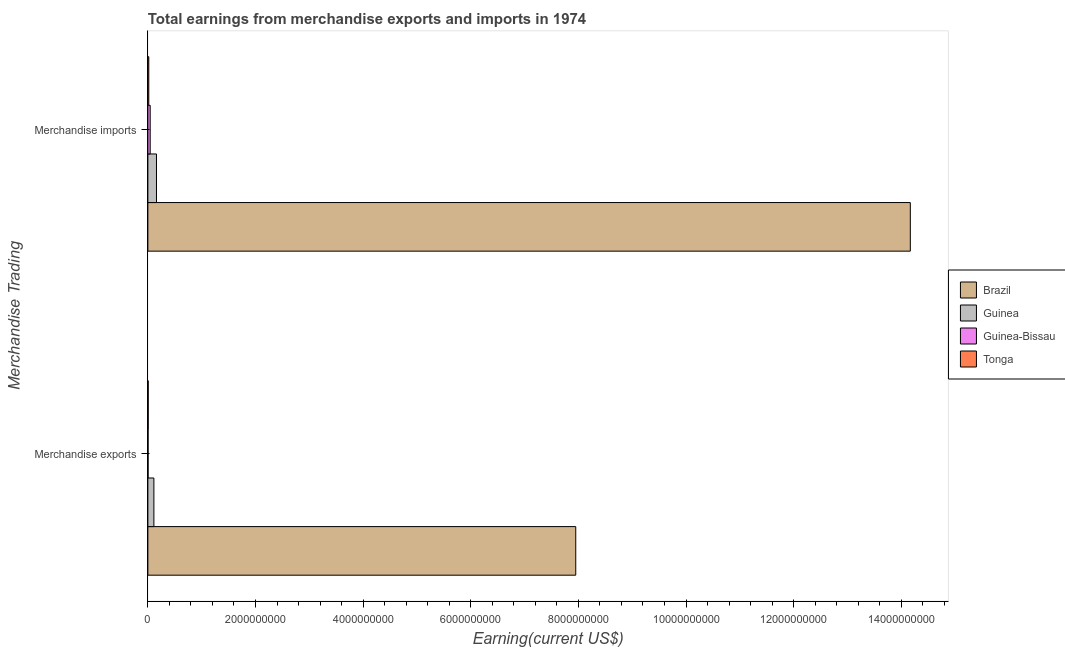How many different coloured bars are there?
Keep it short and to the point. 4. How many groups of bars are there?
Offer a terse response. 2. Are the number of bars on each tick of the Y-axis equal?
Provide a succinct answer. Yes. How many bars are there on the 1st tick from the top?
Keep it short and to the point. 4. How many bars are there on the 1st tick from the bottom?
Keep it short and to the point. 4. What is the label of the 1st group of bars from the top?
Give a very brief answer. Merchandise imports. What is the earnings from merchandise imports in Tonga?
Give a very brief answer. 1.70e+07. Across all countries, what is the maximum earnings from merchandise exports?
Provide a short and direct response. 7.95e+09. Across all countries, what is the minimum earnings from merchandise imports?
Your answer should be very brief. 1.70e+07. In which country was the earnings from merchandise imports maximum?
Offer a terse response. Brazil. In which country was the earnings from merchandise exports minimum?
Your response must be concise. Guinea-Bissau. What is the total earnings from merchandise exports in the graph?
Provide a short and direct response. 8.07e+09. What is the difference between the earnings from merchandise exports in Guinea-Bissau and that in Tonga?
Make the answer very short. -2.74e+06. What is the difference between the earnings from merchandise exports in Brazil and the earnings from merchandise imports in Tonga?
Give a very brief answer. 7.93e+09. What is the average earnings from merchandise exports per country?
Your answer should be very brief. 2.02e+09. What is the difference between the earnings from merchandise imports and earnings from merchandise exports in Tonga?
Your response must be concise. 1.04e+07. What is the ratio of the earnings from merchandise imports in Tonga to that in Brazil?
Provide a short and direct response. 0. Is the earnings from merchandise imports in Guinea-Bissau less than that in Tonga?
Offer a very short reply. No. What does the 4th bar from the top in Merchandise imports represents?
Your response must be concise. Brazil. What does the 4th bar from the bottom in Merchandise exports represents?
Ensure brevity in your answer.  Tonga. Are all the bars in the graph horizontal?
Provide a short and direct response. Yes. How many countries are there in the graph?
Ensure brevity in your answer.  4. What is the difference between two consecutive major ticks on the X-axis?
Give a very brief answer. 2.00e+09. Does the graph contain grids?
Provide a succinct answer. No. Where does the legend appear in the graph?
Give a very brief answer. Center right. How many legend labels are there?
Keep it short and to the point. 4. What is the title of the graph?
Give a very brief answer. Total earnings from merchandise exports and imports in 1974. What is the label or title of the X-axis?
Provide a short and direct response. Earning(current US$). What is the label or title of the Y-axis?
Your answer should be very brief. Merchandise Trading. What is the Earning(current US$) of Brazil in Merchandise exports?
Keep it short and to the point. 7.95e+09. What is the Earning(current US$) in Guinea in Merchandise exports?
Your answer should be very brief. 1.12e+08. What is the Earning(current US$) of Guinea-Bissau in Merchandise exports?
Offer a terse response. 3.87e+06. What is the Earning(current US$) in Tonga in Merchandise exports?
Offer a terse response. 6.61e+06. What is the Earning(current US$) of Brazil in Merchandise imports?
Provide a succinct answer. 1.42e+1. What is the Earning(current US$) of Guinea in Merchandise imports?
Your answer should be compact. 1.60e+08. What is the Earning(current US$) of Guinea-Bissau in Merchandise imports?
Provide a short and direct response. 4.31e+07. What is the Earning(current US$) in Tonga in Merchandise imports?
Give a very brief answer. 1.70e+07. Across all Merchandise Trading, what is the maximum Earning(current US$) in Brazil?
Offer a terse response. 1.42e+1. Across all Merchandise Trading, what is the maximum Earning(current US$) of Guinea?
Keep it short and to the point. 1.60e+08. Across all Merchandise Trading, what is the maximum Earning(current US$) of Guinea-Bissau?
Provide a short and direct response. 4.31e+07. Across all Merchandise Trading, what is the maximum Earning(current US$) of Tonga?
Keep it short and to the point. 1.70e+07. Across all Merchandise Trading, what is the minimum Earning(current US$) in Brazil?
Make the answer very short. 7.95e+09. Across all Merchandise Trading, what is the minimum Earning(current US$) of Guinea?
Offer a terse response. 1.12e+08. Across all Merchandise Trading, what is the minimum Earning(current US$) of Guinea-Bissau?
Offer a very short reply. 3.87e+06. Across all Merchandise Trading, what is the minimum Earning(current US$) of Tonga?
Offer a very short reply. 6.61e+06. What is the total Earning(current US$) of Brazil in the graph?
Make the answer very short. 2.21e+1. What is the total Earning(current US$) of Guinea in the graph?
Ensure brevity in your answer.  2.72e+08. What is the total Earning(current US$) of Guinea-Bissau in the graph?
Your response must be concise. 4.70e+07. What is the total Earning(current US$) of Tonga in the graph?
Your answer should be very brief. 2.36e+07. What is the difference between the Earning(current US$) of Brazil in Merchandise exports and that in Merchandise imports?
Your answer should be compact. -6.22e+09. What is the difference between the Earning(current US$) of Guinea in Merchandise exports and that in Merchandise imports?
Provide a succinct answer. -4.80e+07. What is the difference between the Earning(current US$) of Guinea-Bissau in Merchandise exports and that in Merchandise imports?
Your answer should be very brief. -3.92e+07. What is the difference between the Earning(current US$) of Tonga in Merchandise exports and that in Merchandise imports?
Make the answer very short. -1.04e+07. What is the difference between the Earning(current US$) of Brazil in Merchandise exports and the Earning(current US$) of Guinea in Merchandise imports?
Offer a terse response. 7.79e+09. What is the difference between the Earning(current US$) of Brazil in Merchandise exports and the Earning(current US$) of Guinea-Bissau in Merchandise imports?
Give a very brief answer. 7.91e+09. What is the difference between the Earning(current US$) of Brazil in Merchandise exports and the Earning(current US$) of Tonga in Merchandise imports?
Give a very brief answer. 7.93e+09. What is the difference between the Earning(current US$) in Guinea in Merchandise exports and the Earning(current US$) in Guinea-Bissau in Merchandise imports?
Keep it short and to the point. 6.89e+07. What is the difference between the Earning(current US$) in Guinea in Merchandise exports and the Earning(current US$) in Tonga in Merchandise imports?
Offer a very short reply. 9.50e+07. What is the difference between the Earning(current US$) in Guinea-Bissau in Merchandise exports and the Earning(current US$) in Tonga in Merchandise imports?
Your response must be concise. -1.31e+07. What is the average Earning(current US$) of Brazil per Merchandise Trading?
Give a very brief answer. 1.11e+1. What is the average Earning(current US$) in Guinea per Merchandise Trading?
Keep it short and to the point. 1.36e+08. What is the average Earning(current US$) of Guinea-Bissau per Merchandise Trading?
Offer a terse response. 2.35e+07. What is the average Earning(current US$) of Tonga per Merchandise Trading?
Make the answer very short. 1.18e+07. What is the difference between the Earning(current US$) of Brazil and Earning(current US$) of Guinea in Merchandise exports?
Give a very brief answer. 7.84e+09. What is the difference between the Earning(current US$) of Brazil and Earning(current US$) of Guinea-Bissau in Merchandise exports?
Offer a very short reply. 7.95e+09. What is the difference between the Earning(current US$) of Brazil and Earning(current US$) of Tonga in Merchandise exports?
Keep it short and to the point. 7.94e+09. What is the difference between the Earning(current US$) of Guinea and Earning(current US$) of Guinea-Bissau in Merchandise exports?
Your response must be concise. 1.08e+08. What is the difference between the Earning(current US$) in Guinea and Earning(current US$) in Tonga in Merchandise exports?
Make the answer very short. 1.05e+08. What is the difference between the Earning(current US$) of Guinea-Bissau and Earning(current US$) of Tonga in Merchandise exports?
Give a very brief answer. -2.74e+06. What is the difference between the Earning(current US$) of Brazil and Earning(current US$) of Guinea in Merchandise imports?
Your response must be concise. 1.40e+1. What is the difference between the Earning(current US$) of Brazil and Earning(current US$) of Guinea-Bissau in Merchandise imports?
Your response must be concise. 1.41e+1. What is the difference between the Earning(current US$) in Brazil and Earning(current US$) in Tonga in Merchandise imports?
Make the answer very short. 1.42e+1. What is the difference between the Earning(current US$) of Guinea and Earning(current US$) of Guinea-Bissau in Merchandise imports?
Ensure brevity in your answer.  1.17e+08. What is the difference between the Earning(current US$) of Guinea and Earning(current US$) of Tonga in Merchandise imports?
Offer a terse response. 1.43e+08. What is the difference between the Earning(current US$) in Guinea-Bissau and Earning(current US$) in Tonga in Merchandise imports?
Offer a terse response. 2.61e+07. What is the ratio of the Earning(current US$) of Brazil in Merchandise exports to that in Merchandise imports?
Offer a very short reply. 0.56. What is the ratio of the Earning(current US$) of Guinea-Bissau in Merchandise exports to that in Merchandise imports?
Keep it short and to the point. 0.09. What is the ratio of the Earning(current US$) in Tonga in Merchandise exports to that in Merchandise imports?
Your answer should be compact. 0.39. What is the difference between the highest and the second highest Earning(current US$) in Brazil?
Ensure brevity in your answer.  6.22e+09. What is the difference between the highest and the second highest Earning(current US$) in Guinea?
Your response must be concise. 4.80e+07. What is the difference between the highest and the second highest Earning(current US$) of Guinea-Bissau?
Offer a very short reply. 3.92e+07. What is the difference between the highest and the second highest Earning(current US$) of Tonga?
Provide a succinct answer. 1.04e+07. What is the difference between the highest and the lowest Earning(current US$) in Brazil?
Your answer should be compact. 6.22e+09. What is the difference between the highest and the lowest Earning(current US$) of Guinea?
Offer a very short reply. 4.80e+07. What is the difference between the highest and the lowest Earning(current US$) of Guinea-Bissau?
Provide a short and direct response. 3.92e+07. What is the difference between the highest and the lowest Earning(current US$) in Tonga?
Offer a terse response. 1.04e+07. 